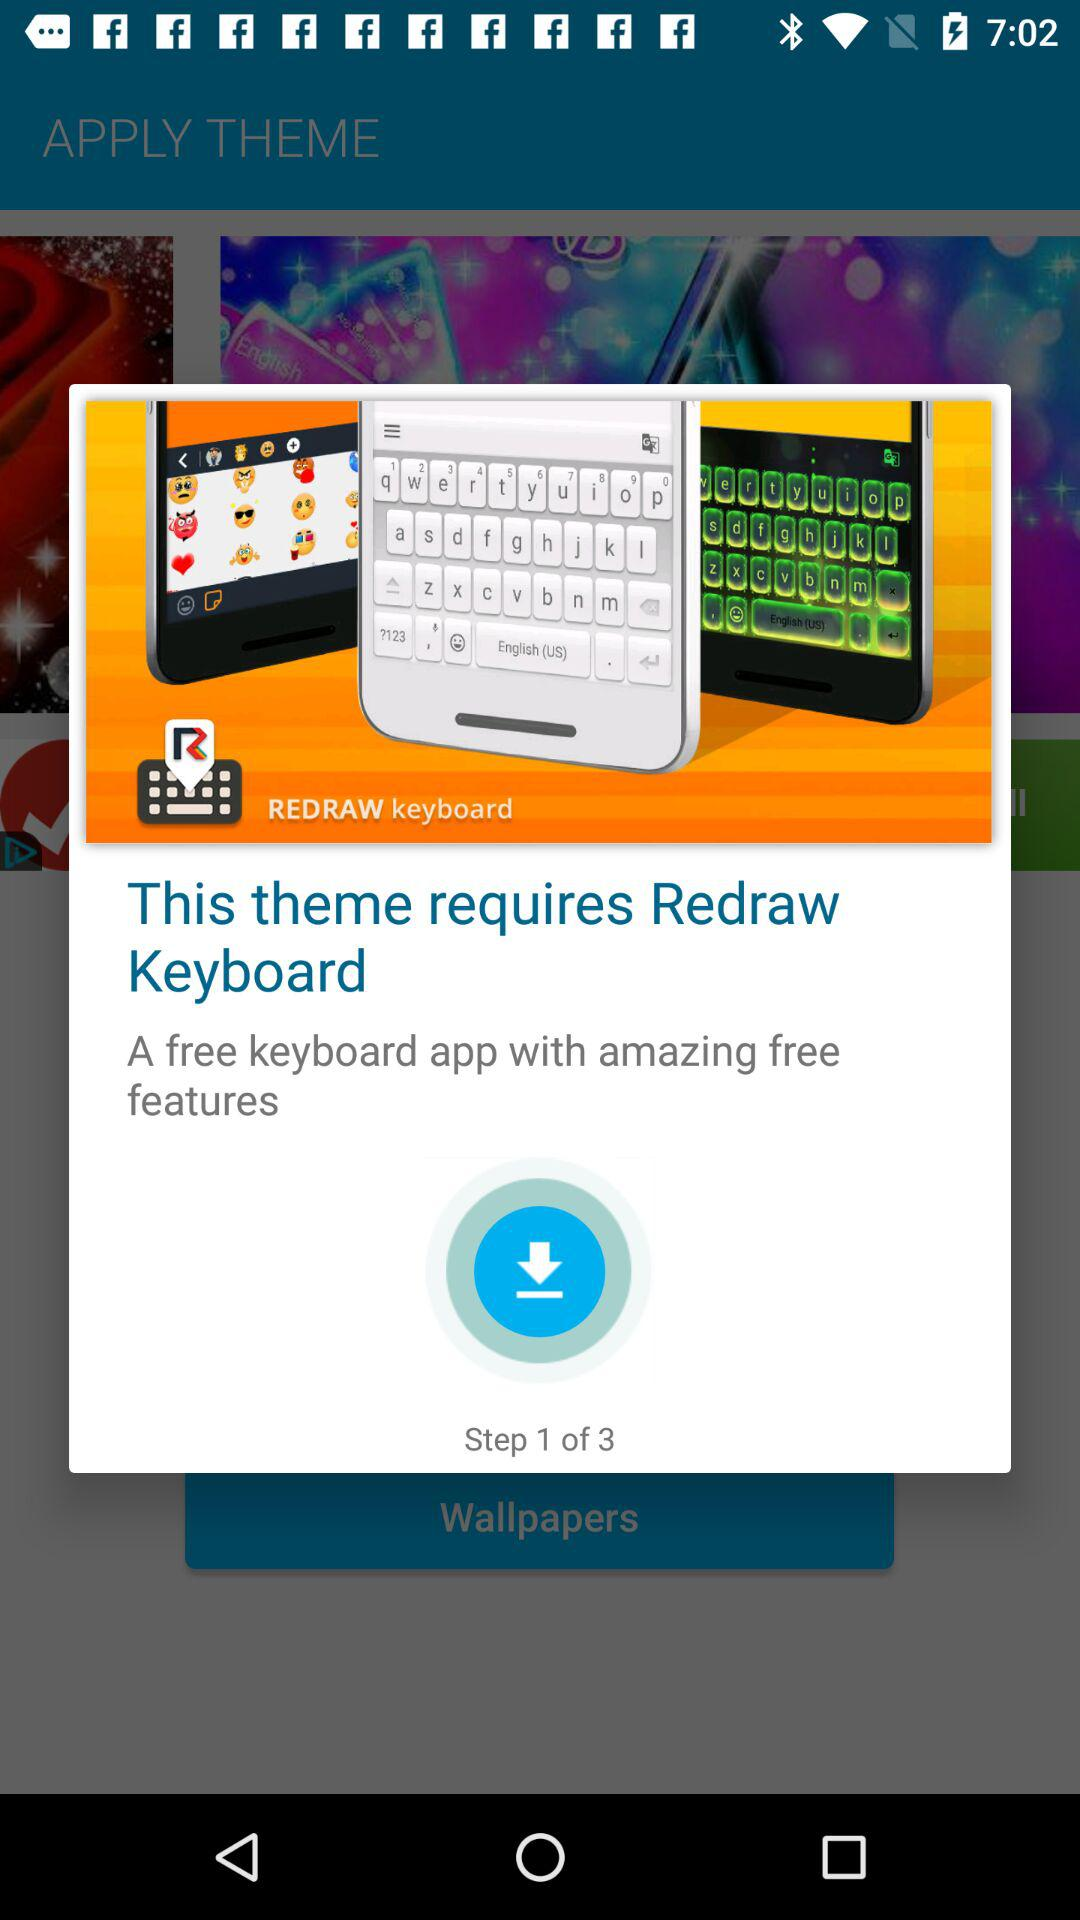How many steps in total are there? There are 3 steps in total. 